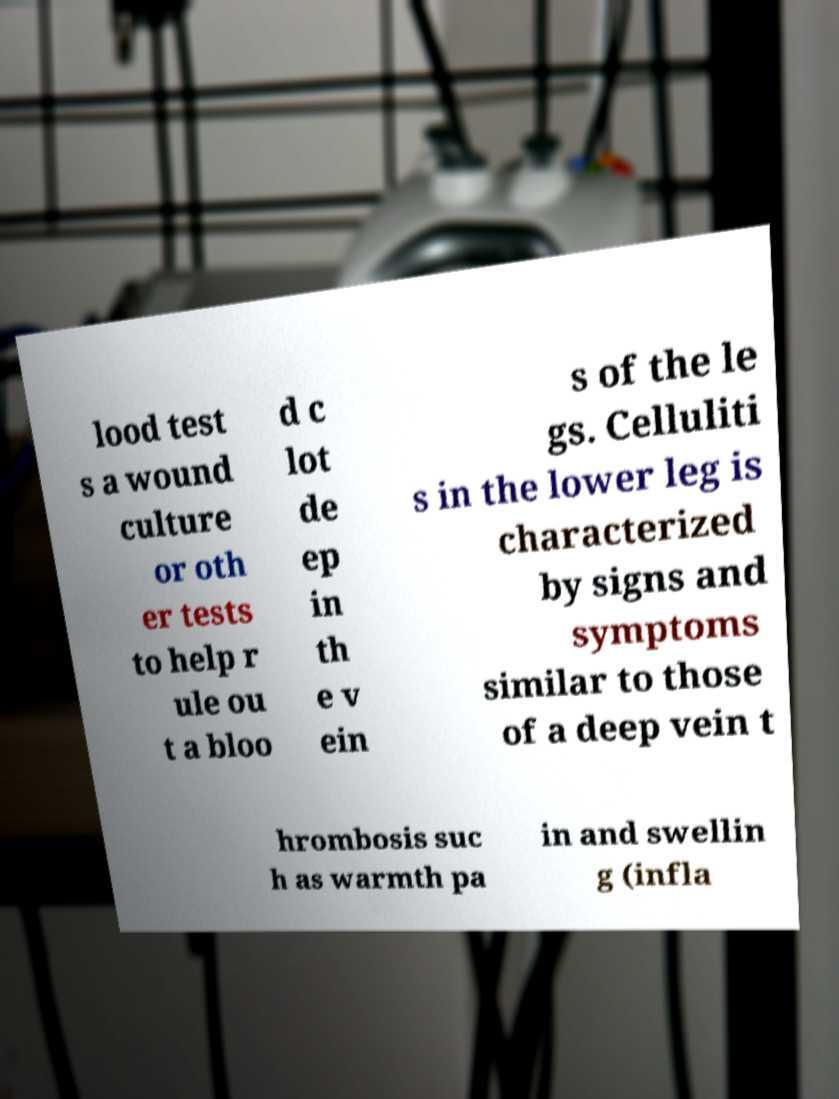Can you accurately transcribe the text from the provided image for me? lood test s a wound culture or oth er tests to help r ule ou t a bloo d c lot de ep in th e v ein s of the le gs. Celluliti s in the lower leg is characterized by signs and symptoms similar to those of a deep vein t hrombosis suc h as warmth pa in and swellin g (infla 